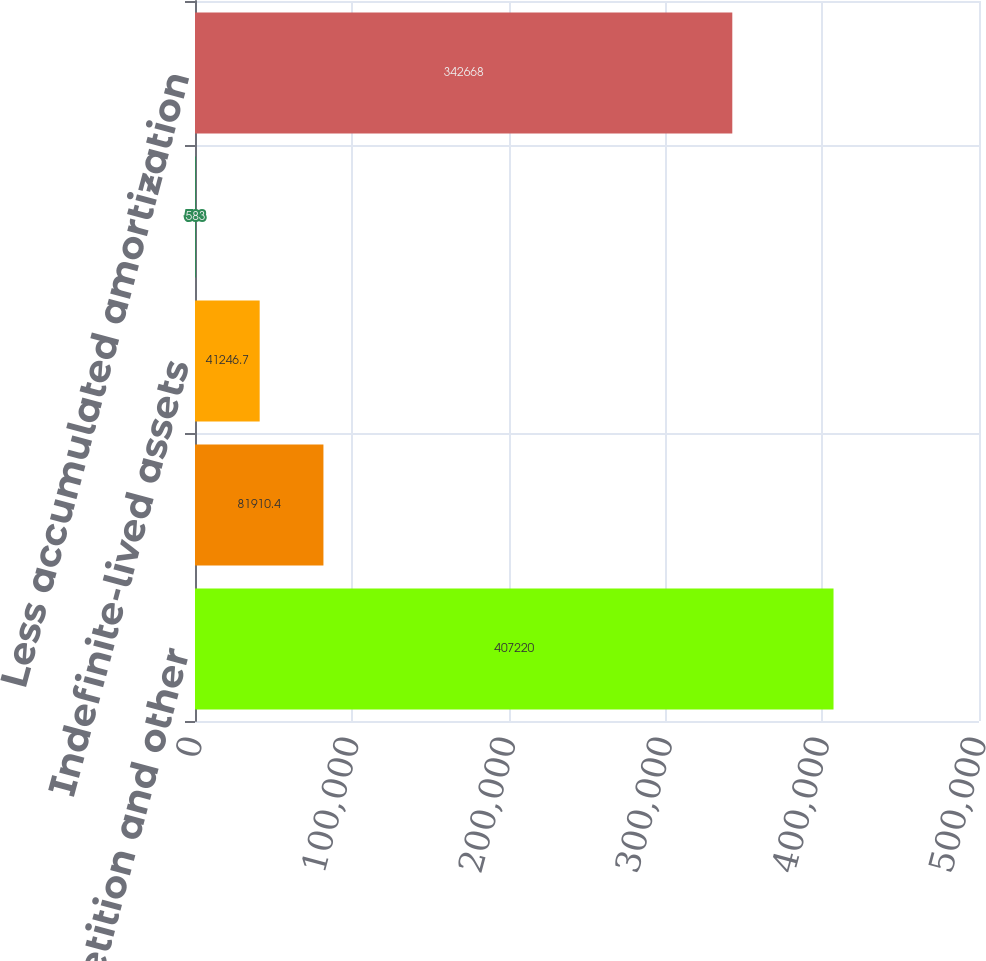Convert chart. <chart><loc_0><loc_0><loc_500><loc_500><bar_chart><fcel>Noncompetition and other<fcel>Lease agreements<fcel>Indefinite-lived assets<fcel>Other<fcel>Less accumulated amortization<nl><fcel>407220<fcel>81910.4<fcel>41246.7<fcel>583<fcel>342668<nl></chart> 